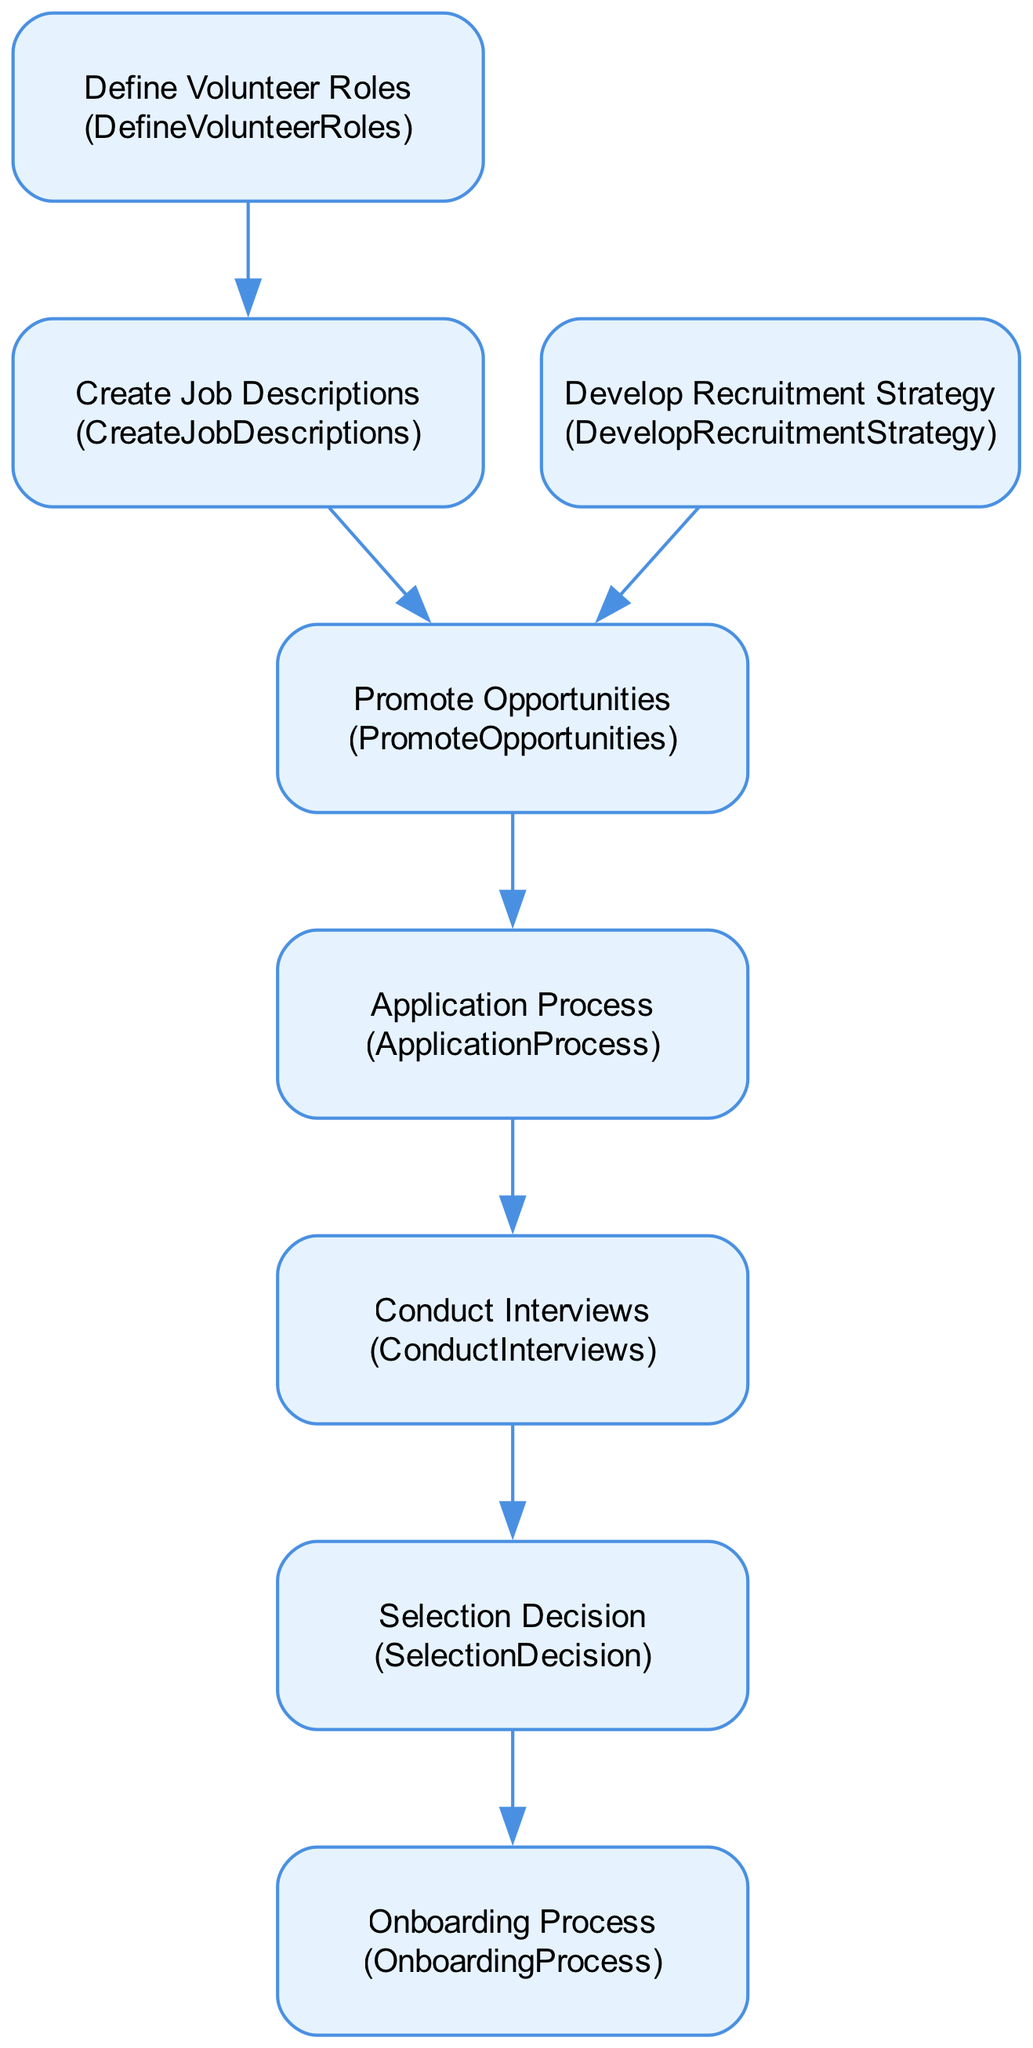What is the first step in the volunteer recruitment process? The first step is indicated by the starting node, which is "Define Volunteer Roles." This node does not have any incoming edges, showing that it's the initial task in the process.
Answer: Define Volunteer Roles How many nodes are present in the diagram? Each unique task in the recruitment process represents a node. By counting these distinct tasks, we find there are a total of 8 nodes.
Answer: 8 Which node follows "Promote Opportunities"? Following the directional flow from "Promote Opportunities," the next node is "Application Process," indicated by an outgoing edge leading to it from "Promote Opportunities."
Answer: Application Process What are the two tasks that are immediate predecessors to "Selection Decision"? To find immediate predecessors, we trace incoming edges to "Selection Decision." The two tasks directly leading into it are "Conduct Interviews" and "Application Process."
Answer: Conduct Interviews, Application Process How many interdependencies are there in the diagram? Interdependencies are represented by edges connecting the nodes. By counting these edges, we see there are 7 interdependencies.
Answer: 7 Which tasks lead to the "Onboarding Process"? The only task leading to "Onboarding Process" is "Selection Decision," which has a direct outgoing edge to "Onboarding Process."
Answer: Selection Decision What is the relationship between "Develop Recruitment Strategy" and "Promote Opportunities"? The relationship is expressed through a directed edge from "Develop Recruitment Strategy" to "Promote Opportunities," indicating that the recruitment strategy must be developed before promoting opportunities.
Answer: Develop Recruitment Strategy ➔ Promote Opportunities Which task must be completed before creating job descriptions? The task that must be completed first is "Define Volunteer Roles," as it is the direct predecessor to "Create Job Descriptions," indicated by a directed edge.
Answer: Define Volunteer Roles 